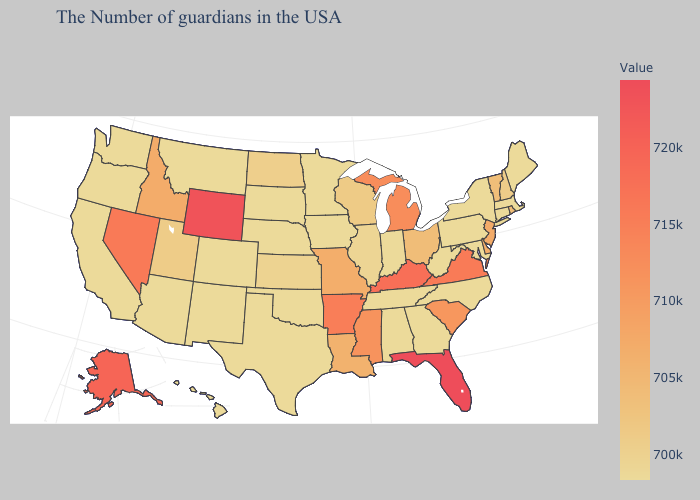Does Idaho have the highest value in the West?
Short answer required. No. Among the states that border New York , does New Jersey have the highest value?
Concise answer only. Yes. Which states have the lowest value in the Northeast?
Quick response, please. Maine, Massachusetts, Connecticut, New York, Pennsylvania. Which states hav the highest value in the Northeast?
Be succinct. New Jersey. Does New Jersey have the highest value in the Northeast?
Concise answer only. Yes. Among the states that border Utah , which have the highest value?
Keep it brief. Wyoming. 